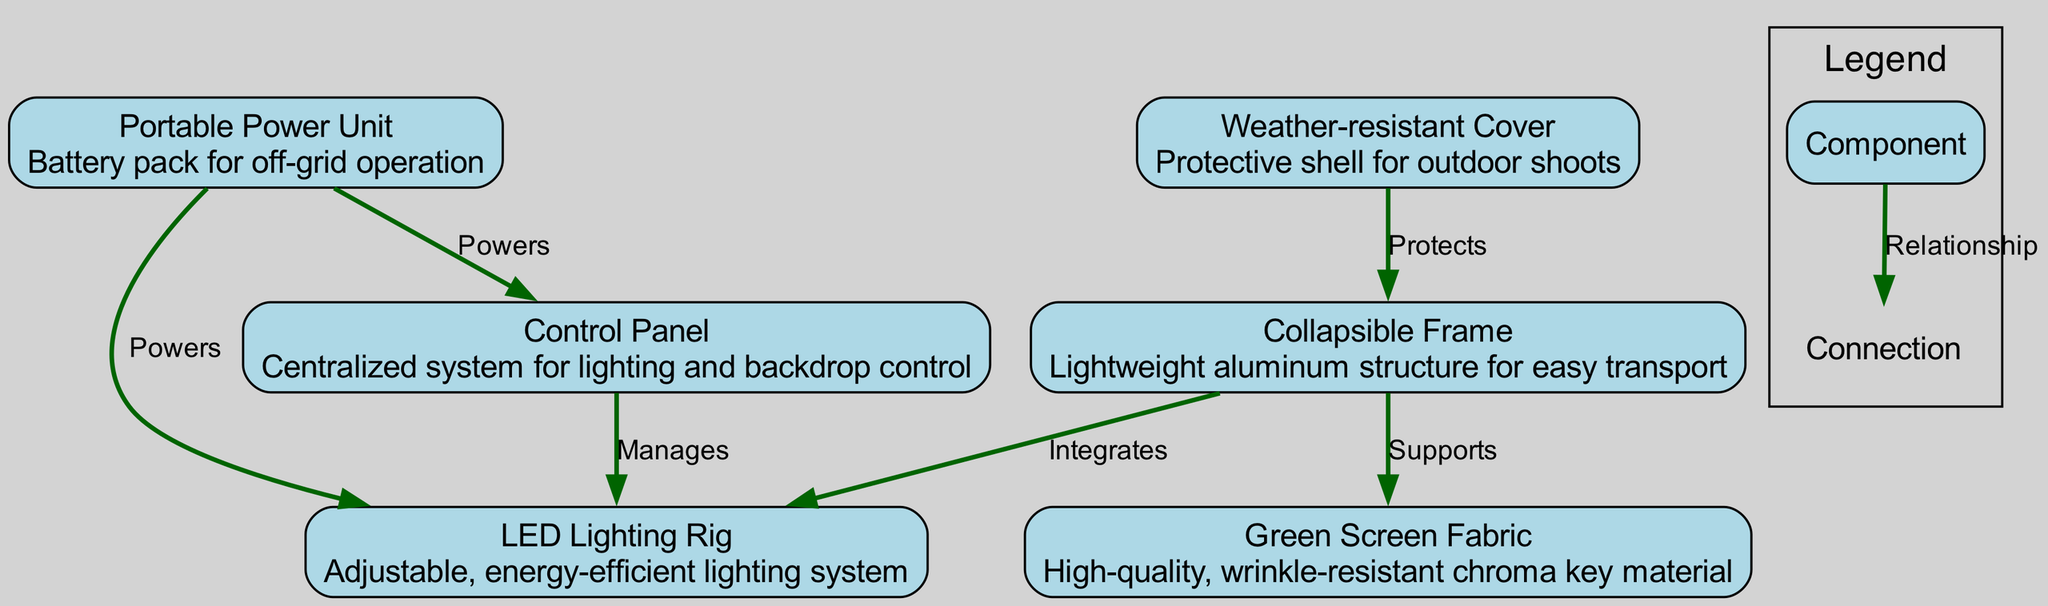What is the total number of nodes in the diagram? The diagram lists six components: Collapsible Frame, Green Screen Fabric, LED Lighting Rig, Control Panel, Portable Power Unit, and Weather-resistant Cover. Therefore, the total number of nodes is 6.
Answer: 6 What material is used for the Green Screen Fabric? The description of the Green Screen Fabric states that it is made from high-quality, wrinkle-resistant chroma key material. Thus, the material is chroma key material.
Answer: chroma key material Which node powers the LED Lighting Rig? The LED Lighting Rig is powered by two sources: the Portable Power Unit and is managed by the Control Panel. However, from the context of the question, the primary one directly identified is the Portable Power Unit.
Answer: Portable Power Unit What relationship exists between the Collapsible Frame and the Green Screen Fabric? The relationship labeled in the diagram between these two nodes is "Supports". This implies that the frame is used to hold or support the green screen fabric.
Answer: Supports How many edges originate from the Portable Power Unit? In the diagram, there are two edges that originate from the Portable Power Unit: one to the LED Lighting Rig (powers) and another to the Control Panel (powers). Therefore, there are 2 edges.
Answer: 2 Which component provides protection for the Collapsible Frame? The Weather-resistant Cover is designed to provide protection for the Collapsible Frame during outdoor shoots. Thus, it is the component that offers protection.
Answer: Weather-resistant Cover What is the main function of the Control Panel in the diagram? The Control Panel serves the main function of managing the LED Lighting Rig according to the relationship described in the diagram. Therefore, its primary function is management.
Answer: Manages What type of lighting system is described in the LED Lighting Rig? The description of the LED Lighting Rig indicates that it is an adjustable and energy-efficient lighting system. Therefore, the type of lighting system is energy-efficient.
Answer: energy-efficient What is the purpose of the Portable Power Unit? The Portable Power Unit is described in the diagram as a battery pack that enables off-grid operation for the studio. Thus, its purpose is to provide power where electrical outlets are not available.
Answer: off-grid operation 